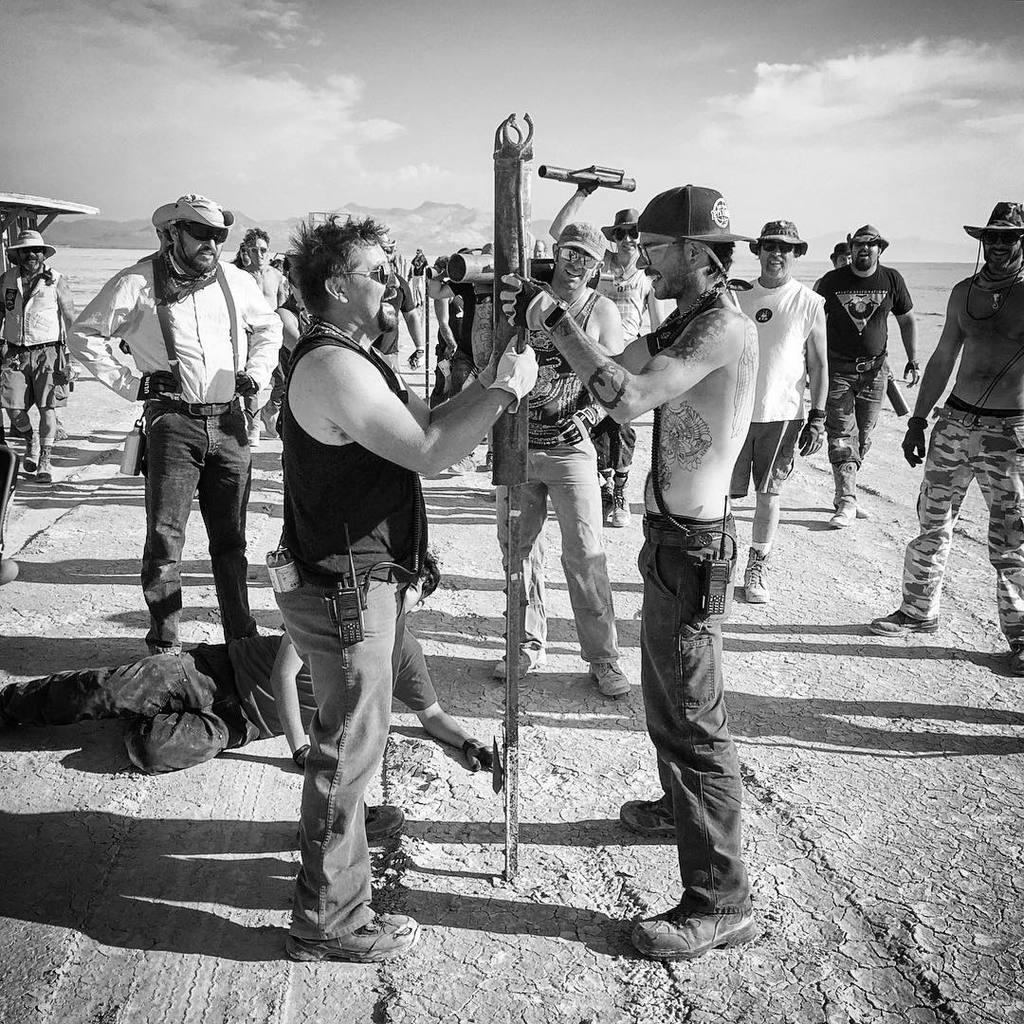Describe this image in one or two sentences. This is a black and white image. In this image we can see people standing on the ground and one of them is lying on the ground. In the background there are hills and sky with clouds. 